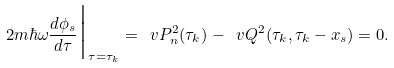<formula> <loc_0><loc_0><loc_500><loc_500>2 m \hbar { \omega } \frac { d \phi _ { s } } { d \tau } \Big | _ { \tau = \tau _ { k } } = \ v P _ { n } ^ { 2 } ( \tau _ { k } ) - \ v Q ^ { 2 } ( \tau _ { k } , \tau _ { k } - x _ { s } ) = 0 .</formula> 